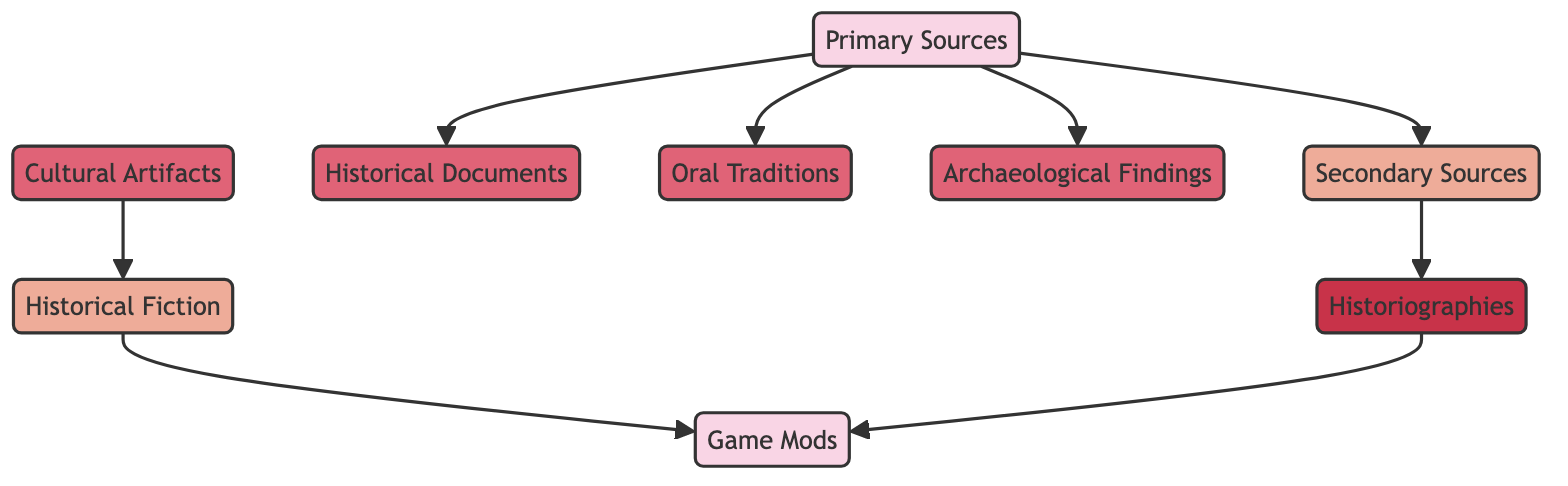What is the total number of nodes in the diagram? The diagram includes 9 distinct nodes: Primary Sources, Secondary Sources, Historical Documents, Oral Traditions, Archaeological Findings, Historiographies, Cultural Artifacts, Historical Fiction, and Game Mods. Counting these gives a total of 9 nodes.
Answer: 9 Which source type leads directly to Game Mods? The relationships indicate Historical Fiction and Historiographies both lead to Game Mods. Since the question asks for the source types, the key sources are Historical Fiction and Historiographies.
Answer: Historical Fiction, Historiographies What type of sources are considered Primary Sources? Primary Sources consist of original documents or artifacts, including Historical Documents, Oral Traditions, and Archaeological Findings. Since these three elements are directly linked to the Primary Sources node, they define the category.
Answer: Historical Documents, Oral Traditions, Archaeological Findings How many edges connect Primary Sources to other nodes? There are four directed connections (edges) originating from the Primary Sources node, leading to Secondary Sources, Historical Documents, Oral Traditions, and Archaeological Findings. These connections indicate the flow from Primary Sources to each corresponding node.
Answer: 4 What is the relationship between Secondary Sources and Historiographies? The diagram illustrates a directed connection from Secondary Sources to Historiographies. This signifies that Historiographies are derived from the analysis and interpretation of Secondary Sources, making the relationship one of dependency or progression.
Answer: Dependency Which type of sources directly leads to Historical Fiction? According to the directed connections, the Cultural Artifacts node leads directly to Historical Fiction. This relationship indicates that cultural artifacts provide the basis for storytelling within the historical fiction narrative context.
Answer: Cultural Artifacts How many unique source types are listed in the diagram? The diagram lists seven unique source types: Primary Sources, Secondary Sources, Historical Documents, Oral Traditions, Archaeological Findings, Historiographies, and Cultural Artifacts. Each of these represents a distinct category of historical sources.
Answer: 7 Which nodes are in a direct relationship with Game Mods? Game Mods are directly related to Historical Fiction and Historiographies, as indicated by the directed edges pointing from these nodes to Game Mods. The connection signifies that both types contribute to the development of game narratives within mods.
Answer: Historical Fiction, Historiographies What type of source can be classified as Secondary Sources? The diagram defines Secondary Sources as analysis or interpretation of Primary Sources, particularly illustrated by the connection to Historiographies. This classification shows that Secondary Sources reflect a formed understanding based on the initial information from Primary Sources.
Answer: Historiographies 